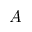<formula> <loc_0><loc_0><loc_500><loc_500>A</formula> 